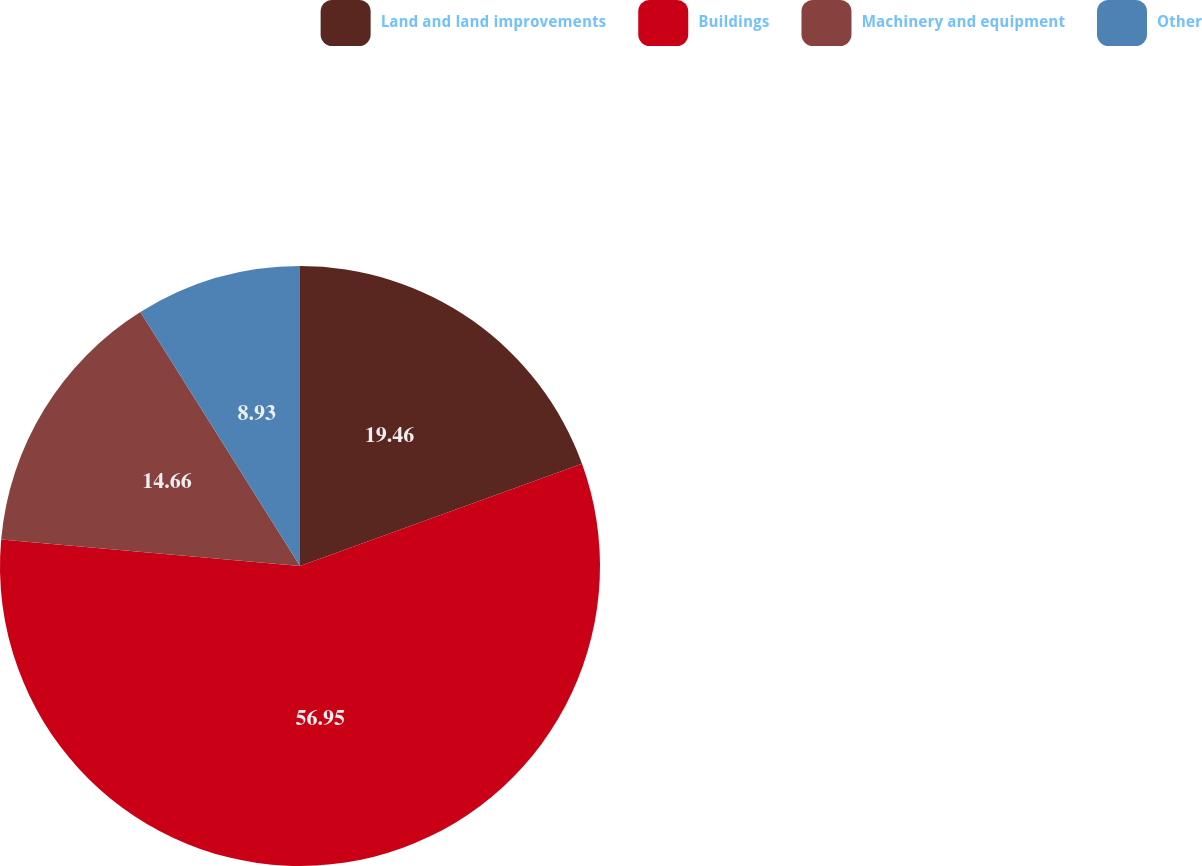Convert chart. <chart><loc_0><loc_0><loc_500><loc_500><pie_chart><fcel>Land and land improvements<fcel>Buildings<fcel>Machinery and equipment<fcel>Other<nl><fcel>19.46%<fcel>56.95%<fcel>14.66%<fcel>8.93%<nl></chart> 